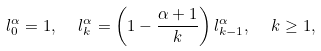<formula> <loc_0><loc_0><loc_500><loc_500>l ^ { \alpha } _ { 0 } = 1 , \ \ l ^ { \alpha } _ { k } = \left ( 1 - \frac { \alpha + 1 } { k } \right ) l ^ { \alpha } _ { k - 1 } , \ \ k \geq 1 ,</formula> 